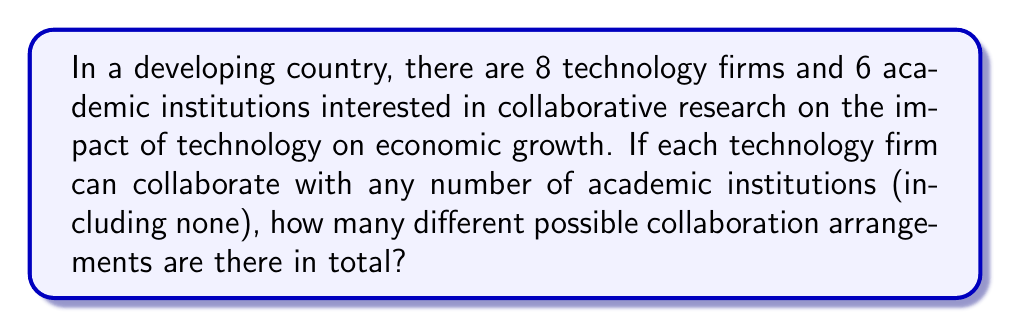Teach me how to tackle this problem. Let's approach this step-by-step:

1) For each academic institution, a technology firm has two choices: to collaborate or not to collaborate.

2) Since there are 6 academic institutions, each technology firm has $2^6 = 64$ possible collaboration patterns.

3) This choice is independent for each of the 8 technology firms.

4) Therefore, we can use the multiplication principle of counting.

5) The total number of possible collaboration arrangements is:

   $$(2^6)^8 = 64^8$$

6) We can simplify this further:

   $$64^8 = (2^6)^8 = 2^{48}$$

7) Therefore, the total number of possible collaboration arrangements is $2^{48}$.
Answer: $2^{48}$ 